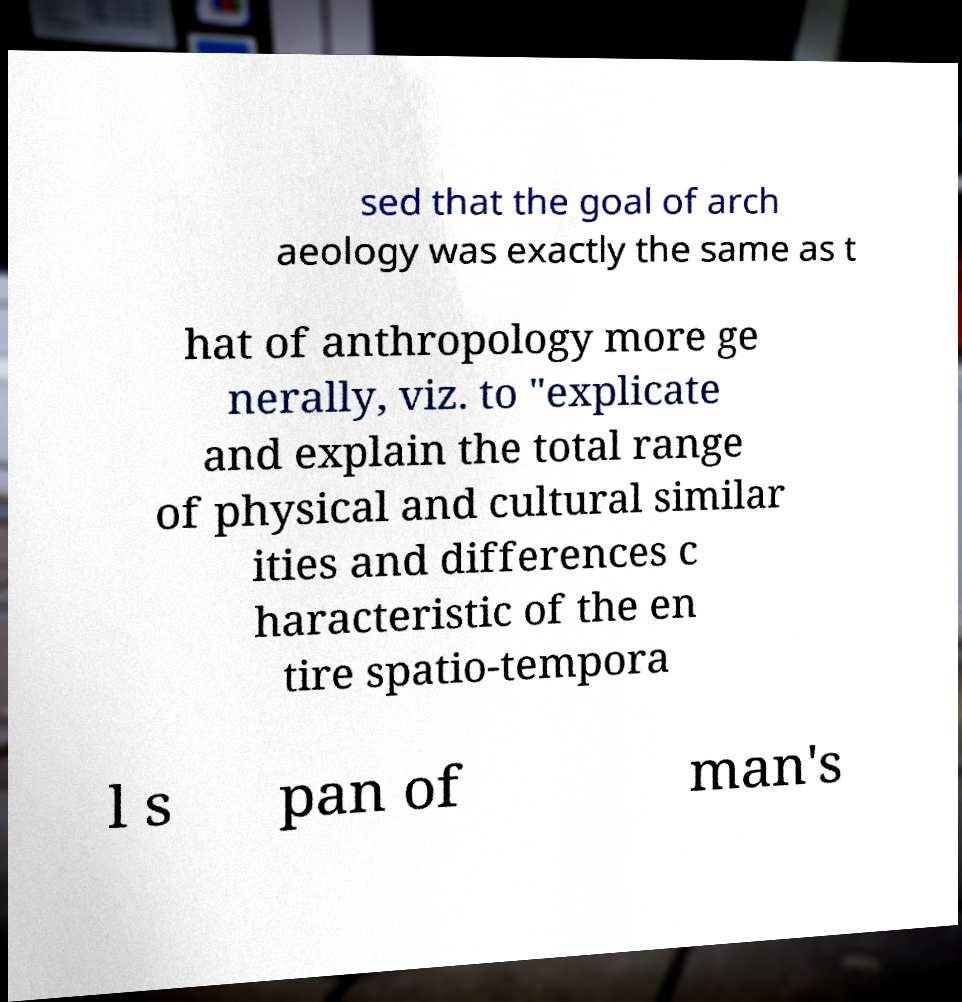Please identify and transcribe the text found in this image. sed that the goal of arch aeology was exactly the same as t hat of anthropology more ge nerally, viz. to "explicate and explain the total range of physical and cultural similar ities and differences c haracteristic of the en tire spatio-tempora l s pan of man's 